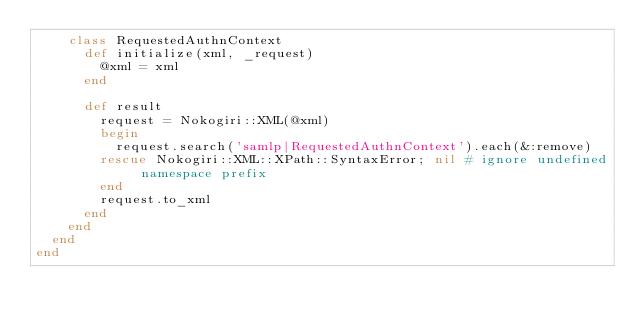<code> <loc_0><loc_0><loc_500><loc_500><_Ruby_>    class RequestedAuthnContext
      def initialize(xml, _request)
        @xml = xml
      end

      def result
        request = Nokogiri::XML(@xml)
        begin
          request.search('samlp|RequestedAuthnContext').each(&:remove)
        rescue Nokogiri::XML::XPath::SyntaxError; nil # ignore undefined namespace prefix
        end
        request.to_xml
      end
    end
  end
end
</code> 